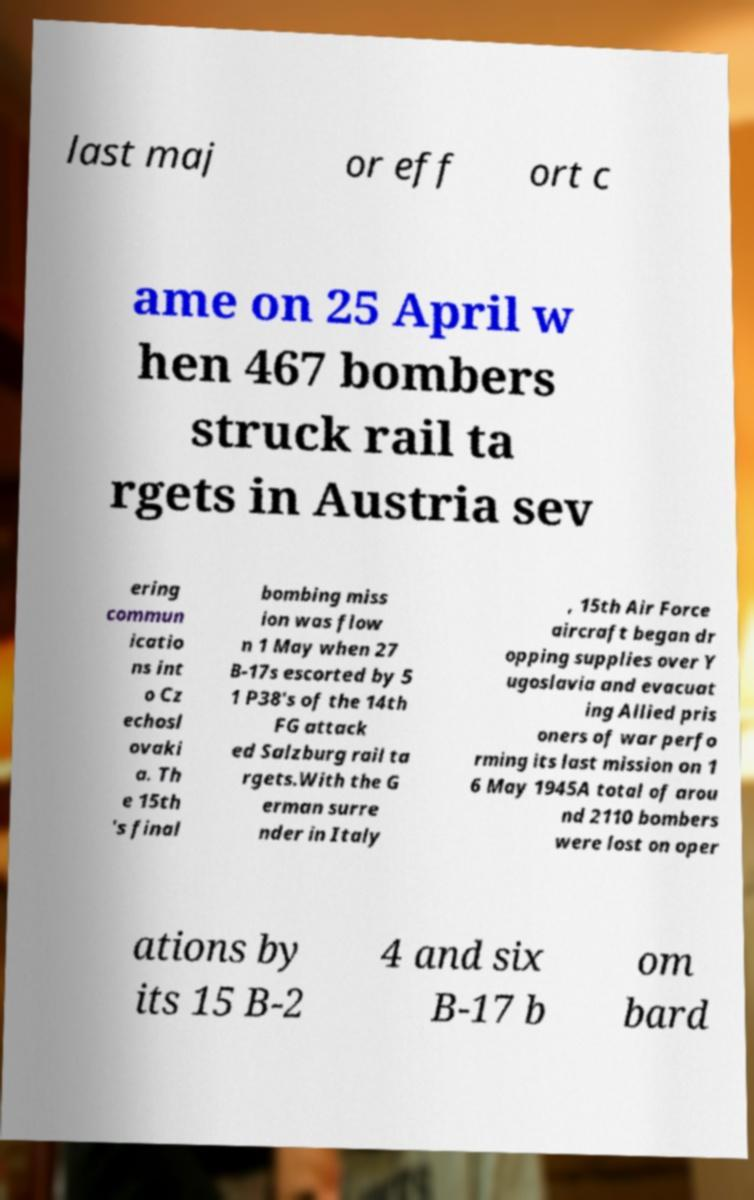What messages or text are displayed in this image? I need them in a readable, typed format. last maj or eff ort c ame on 25 April w hen 467 bombers struck rail ta rgets in Austria sev ering commun icatio ns int o Cz echosl ovaki a. Th e 15th 's final bombing miss ion was flow n 1 May when 27 B-17s escorted by 5 1 P38's of the 14th FG attack ed Salzburg rail ta rgets.With the G erman surre nder in Italy , 15th Air Force aircraft began dr opping supplies over Y ugoslavia and evacuat ing Allied pris oners of war perfo rming its last mission on 1 6 May 1945A total of arou nd 2110 bombers were lost on oper ations by its 15 B-2 4 and six B-17 b om bard 